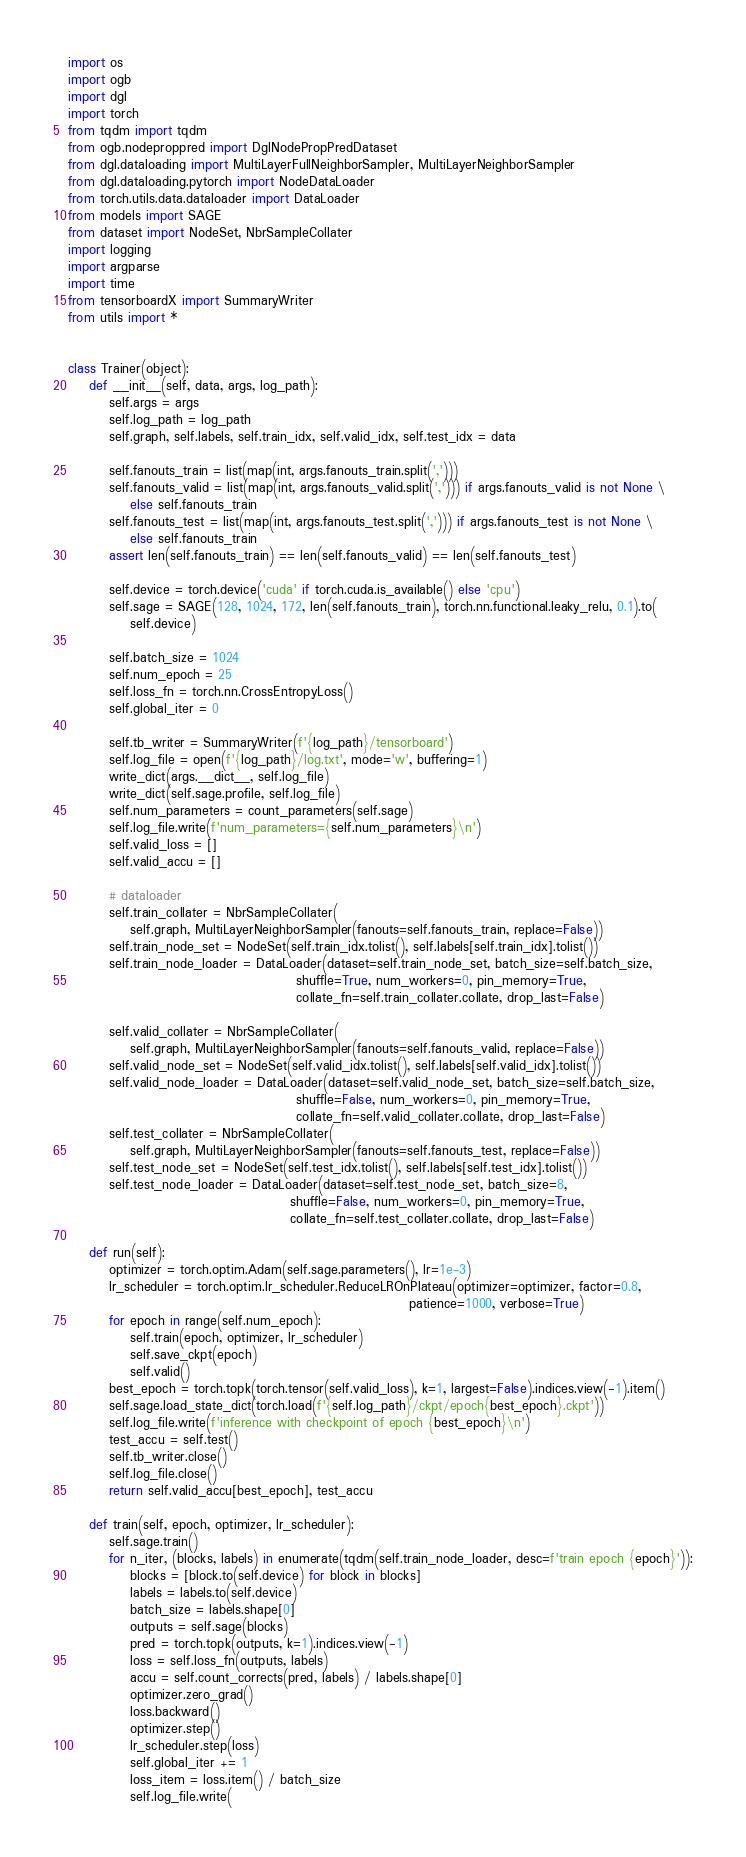<code> <loc_0><loc_0><loc_500><loc_500><_Python_>import os
import ogb
import dgl
import torch
from tqdm import tqdm
from ogb.nodeproppred import DglNodePropPredDataset
from dgl.dataloading import MultiLayerFullNeighborSampler, MultiLayerNeighborSampler
from dgl.dataloading.pytorch import NodeDataLoader
from torch.utils.data.dataloader import DataLoader
from models import SAGE
from dataset import NodeSet, NbrSampleCollater
import logging
import argparse
import time
from tensorboardX import SummaryWriter
from utils import *


class Trainer(object):
    def __init__(self, data, args, log_path):
        self.args = args
        self.log_path = log_path
        self.graph, self.labels, self.train_idx, self.valid_idx, self.test_idx = data

        self.fanouts_train = list(map(int, args.fanouts_train.split(',')))
        self.fanouts_valid = list(map(int, args.fanouts_valid.split(','))) if args.fanouts_valid is not None \
            else self.fanouts_train
        self.fanouts_test = list(map(int, args.fanouts_test.split(','))) if args.fanouts_test is not None \
            else self.fanouts_train
        assert len(self.fanouts_train) == len(self.fanouts_valid) == len(self.fanouts_test)

        self.device = torch.device('cuda' if torch.cuda.is_available() else 'cpu')
        self.sage = SAGE(128, 1024, 172, len(self.fanouts_train), torch.nn.functional.leaky_relu, 0.1).to(
            self.device)

        self.batch_size = 1024
        self.num_epoch = 25
        self.loss_fn = torch.nn.CrossEntropyLoss()
        self.global_iter = 0

        self.tb_writer = SummaryWriter(f'{log_path}/tensorboard')
        self.log_file = open(f'{log_path}/log.txt', mode='w', buffering=1)
        write_dict(args.__dict__, self.log_file)
        write_dict(self.sage.profile, self.log_file)
        self.num_parameters = count_parameters(self.sage)
        self.log_file.write(f'num_parameters={self.num_parameters}\n')
        self.valid_loss = []
        self.valid_accu = []

        # dataloader
        self.train_collater = NbrSampleCollater(
            self.graph, MultiLayerNeighborSampler(fanouts=self.fanouts_train, replace=False))
        self.train_node_set = NodeSet(self.train_idx.tolist(), self.labels[self.train_idx].tolist())
        self.train_node_loader = DataLoader(dataset=self.train_node_set, batch_size=self.batch_size,
                                            shuffle=True, num_workers=0, pin_memory=True,
                                            collate_fn=self.train_collater.collate, drop_last=False)

        self.valid_collater = NbrSampleCollater(
            self.graph, MultiLayerNeighborSampler(fanouts=self.fanouts_valid, replace=False))
        self.valid_node_set = NodeSet(self.valid_idx.tolist(), self.labels[self.valid_idx].tolist())
        self.valid_node_loader = DataLoader(dataset=self.valid_node_set, batch_size=self.batch_size,
                                            shuffle=False, num_workers=0, pin_memory=True,
                                            collate_fn=self.valid_collater.collate, drop_last=False)
        self.test_collater = NbrSampleCollater(
            self.graph, MultiLayerNeighborSampler(fanouts=self.fanouts_test, replace=False))
        self.test_node_set = NodeSet(self.test_idx.tolist(), self.labels[self.test_idx].tolist())
        self.test_node_loader = DataLoader(dataset=self.test_node_set, batch_size=8,
                                           shuffle=False, num_workers=0, pin_memory=True,
                                           collate_fn=self.test_collater.collate, drop_last=False)

    def run(self):
        optimizer = torch.optim.Adam(self.sage.parameters(), lr=1e-3)
        lr_scheduler = torch.optim.lr_scheduler.ReduceLROnPlateau(optimizer=optimizer, factor=0.8,
                                                                  patience=1000, verbose=True)
        for epoch in range(self.num_epoch):
            self.train(epoch, optimizer, lr_scheduler)
            self.save_ckpt(epoch)
            self.valid()
        best_epoch = torch.topk(torch.tensor(self.valid_loss), k=1, largest=False).indices.view(-1).item()
        self.sage.load_state_dict(torch.load(f'{self.log_path}/ckpt/epoch{best_epoch}.ckpt'))
        self.log_file.write(f'inference with checkpoint of epoch {best_epoch}\n')
        test_accu = self.test()
        self.tb_writer.close()
        self.log_file.close()
        return self.valid_accu[best_epoch], test_accu

    def train(self, epoch, optimizer, lr_scheduler):
        self.sage.train()
        for n_iter, (blocks, labels) in enumerate(tqdm(self.train_node_loader, desc=f'train epoch {epoch}')):
            blocks = [block.to(self.device) for block in blocks]
            labels = labels.to(self.device)
            batch_size = labels.shape[0]
            outputs = self.sage(blocks)
            pred = torch.topk(outputs, k=1).indices.view(-1)
            loss = self.loss_fn(outputs, labels)
            accu = self.count_corrects(pred, labels) / labels.shape[0]
            optimizer.zero_grad()
            loss.backward()
            optimizer.step()
            lr_scheduler.step(loss)
            self.global_iter += 1
            loss_item = loss.item() / batch_size
            self.log_file.write(</code> 